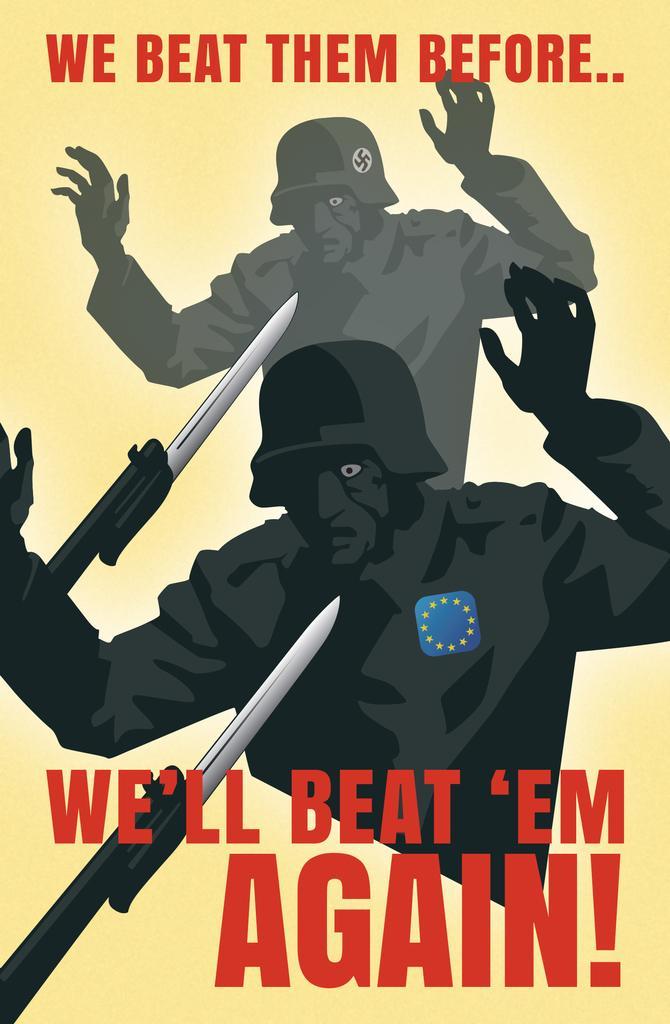Please provide a concise description of this image. This is an animated image with some text and in which we can see depiction of a person and a knife. 